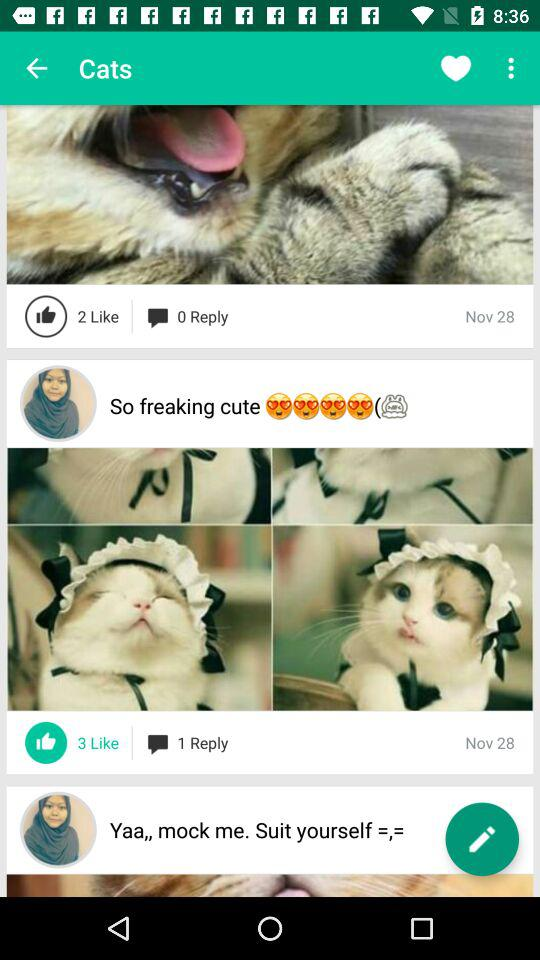When were the images posted by "So freaking cute"? "So freaking cute" posted the images on November 28. 